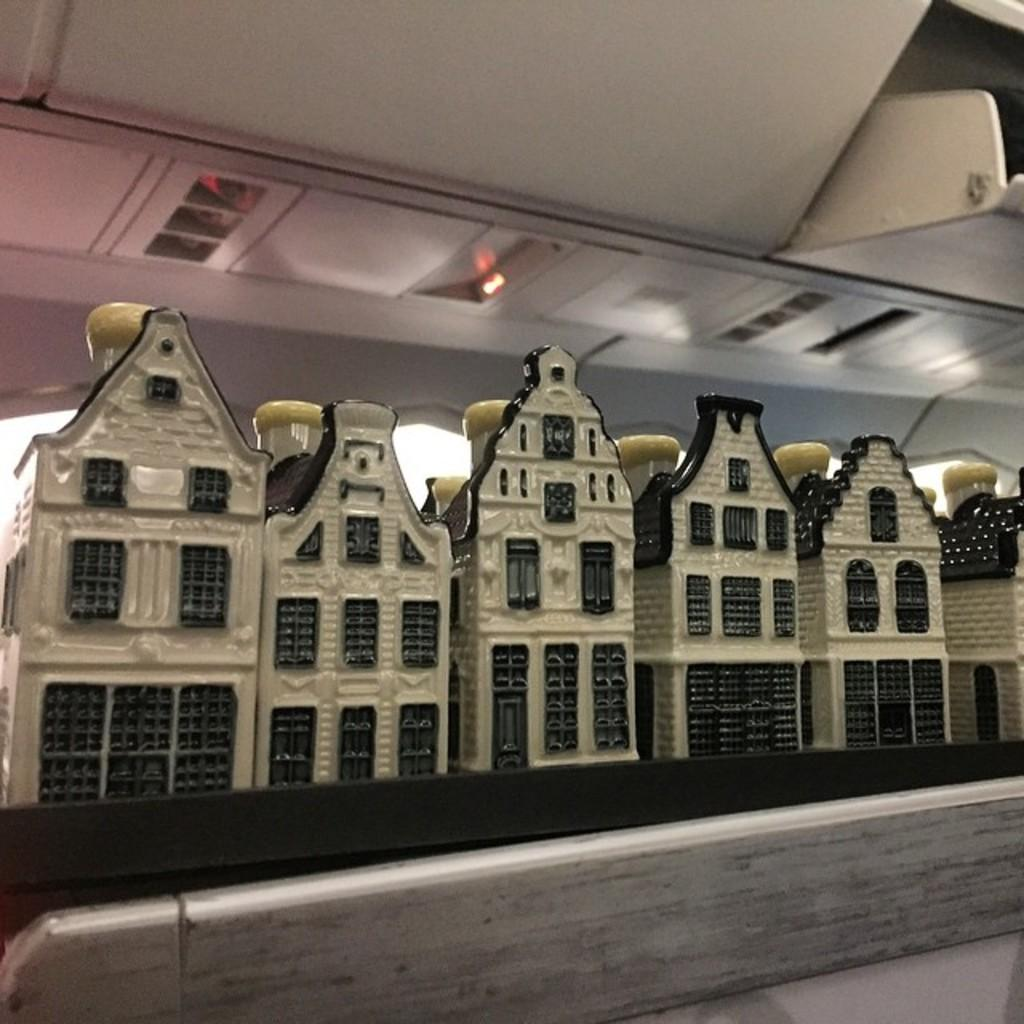What objects can be seen in the image? There are bottles in the image, and they are placed in house-shaped containers. Where are the switches located in the image? The switches are at the top of the image. What type of storage spaces are mentioned in the image? There are cabin storage spaces in the flight. What type of food is being served in the jail in the image? There is no jail or food present in the image; it features bottles in house-shaped containers, switches, and cabin storage spaces. Can you tell me how many brains are visible in the image? There are no brains visible in the image. 